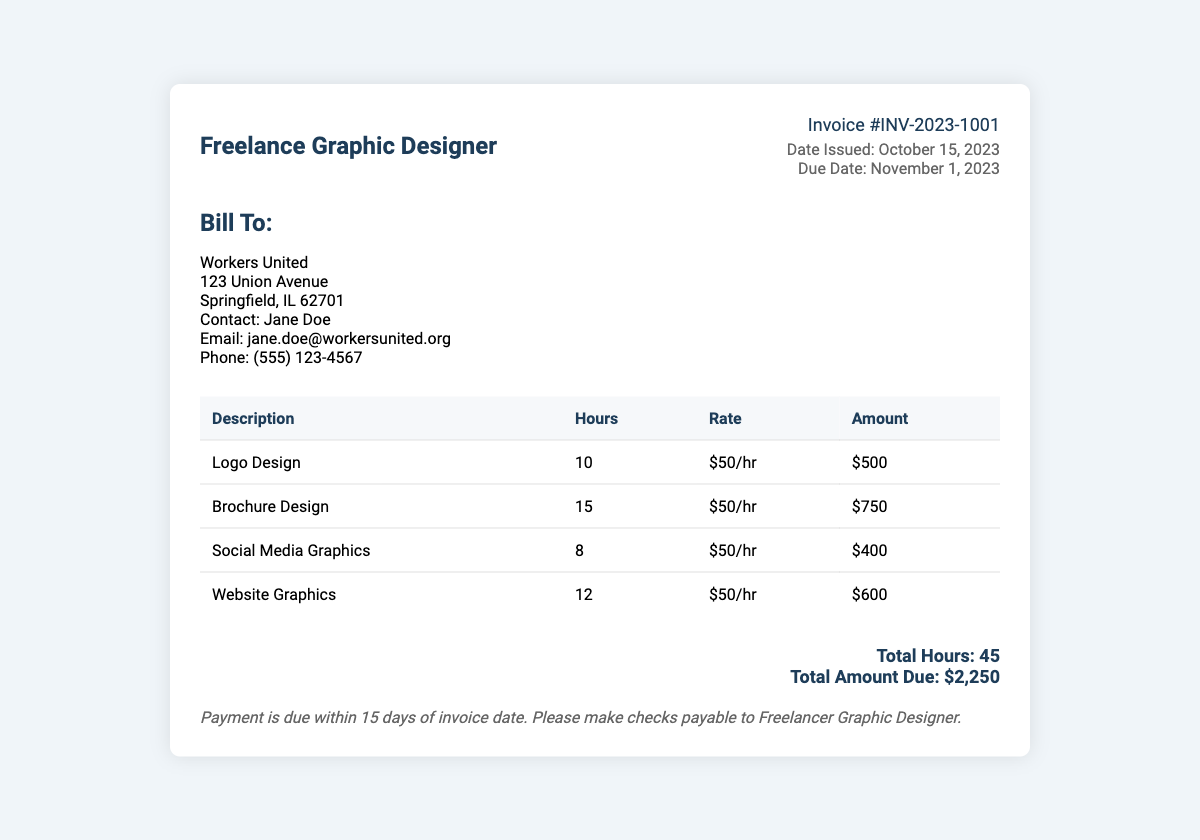What is the invoice number? The invoice number is specified at the top of the document, identifying the transaction uniquely.
Answer: INV-2023-1001 What is the date issued? The date issued indicates when the invoice was created, which is found in the invoice details section.
Answer: October 15, 2023 Who is the contact person for Workers United? The contact person is listed under the "Bill To" section, providing a point of communication for payment.
Answer: Jane Doe What is the total amount due? The total amount due summarizes the overall charge for the services rendered on the invoice.
Answer: $2,250 How many total hours were worked? The total hours reflect the sum of hours spent on all design services provided, calculated from the services table.
Answer: 45 What is the hourly rate for services? The hourly rate is mentioned in each line of the services table and indicates the charge per hour of work.
Answer: $50/hr When is the payment due? The due date specifies by when the payment should be made, providing important financial information.
Answer: November 1, 2023 What service required the most hours? This requires comparing the hours listed for each service to determine which had the highest number.
Answer: Brochure Design 